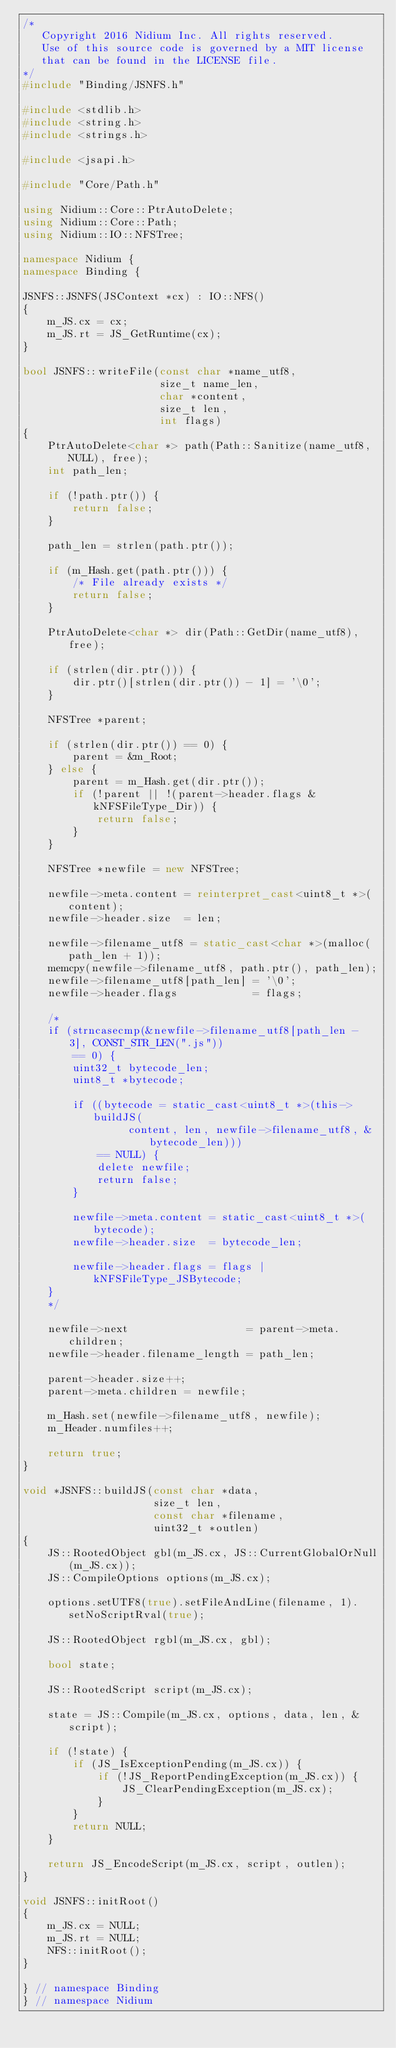<code> <loc_0><loc_0><loc_500><loc_500><_C++_>/*
   Copyright 2016 Nidium Inc. All rights reserved.
   Use of this source code is governed by a MIT license
   that can be found in the LICENSE file.
*/
#include "Binding/JSNFS.h"

#include <stdlib.h>
#include <string.h>
#include <strings.h>

#include <jsapi.h>

#include "Core/Path.h"

using Nidium::Core::PtrAutoDelete;
using Nidium::Core::Path;
using Nidium::IO::NFSTree;

namespace Nidium {
namespace Binding {

JSNFS::JSNFS(JSContext *cx) : IO::NFS()
{
    m_JS.cx = cx;
    m_JS.rt = JS_GetRuntime(cx);
}

bool JSNFS::writeFile(const char *name_utf8,
                      size_t name_len,
                      char *content,
                      size_t len,
                      int flags)
{
    PtrAutoDelete<char *> path(Path::Sanitize(name_utf8, NULL), free);
    int path_len;

    if (!path.ptr()) {
        return false;
    }

    path_len = strlen(path.ptr());

    if (m_Hash.get(path.ptr())) {
        /* File already exists */
        return false;
    }

    PtrAutoDelete<char *> dir(Path::GetDir(name_utf8), free);

    if (strlen(dir.ptr())) {
        dir.ptr()[strlen(dir.ptr()) - 1] = '\0';
    }

    NFSTree *parent;

    if (strlen(dir.ptr()) == 0) {
        parent = &m_Root;
    } else {
        parent = m_Hash.get(dir.ptr());
        if (!parent || !(parent->header.flags & kNFSFileType_Dir)) {
            return false;
        }
    }

    NFSTree *newfile = new NFSTree;

    newfile->meta.content = reinterpret_cast<uint8_t *>(content);
    newfile->header.size  = len;

    newfile->filename_utf8 = static_cast<char *>(malloc(path_len + 1));
    memcpy(newfile->filename_utf8, path.ptr(), path_len);
    newfile->filename_utf8[path_len] = '\0';
    newfile->header.flags            = flags;

    /*
    if (strncasecmp(&newfile->filename_utf8[path_len - 3], CONST_STR_LEN(".js"))
        == 0) {
        uint32_t bytecode_len;
        uint8_t *bytecode;

        if ((bytecode = static_cast<uint8_t *>(this->buildJS(
                 content, len, newfile->filename_utf8, &bytecode_len)))
            == NULL) {
            delete newfile;
            return false;
        }

        newfile->meta.content = static_cast<uint8_t *>(bytecode);
        newfile->header.size  = bytecode_len;

        newfile->header.flags = flags | kNFSFileType_JSBytecode;
    }
    */

    newfile->next                   = parent->meta.children;
    newfile->header.filename_length = path_len;

    parent->header.size++;
    parent->meta.children = newfile;

    m_Hash.set(newfile->filename_utf8, newfile);
    m_Header.numfiles++;

    return true;
}

void *JSNFS::buildJS(const char *data,
                     size_t len,
                     const char *filename,
                     uint32_t *outlen)
{
    JS::RootedObject gbl(m_JS.cx, JS::CurrentGlobalOrNull(m_JS.cx));
    JS::CompileOptions options(m_JS.cx);

    options.setUTF8(true).setFileAndLine(filename, 1).setNoScriptRval(true);

    JS::RootedObject rgbl(m_JS.cx, gbl);

    bool state;

    JS::RootedScript script(m_JS.cx);

    state = JS::Compile(m_JS.cx, options, data, len, &script);

    if (!state) {
        if (JS_IsExceptionPending(m_JS.cx)) {
            if (!JS_ReportPendingException(m_JS.cx)) {
                JS_ClearPendingException(m_JS.cx);
            }
        }
        return NULL;
    }

    return JS_EncodeScript(m_JS.cx, script, outlen);
}

void JSNFS::initRoot()
{
    m_JS.cx = NULL;
    m_JS.rt = NULL;
    NFS::initRoot();
}

} // namespace Binding
} // namespace Nidium
</code> 